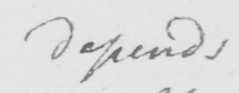Please transcribe the handwritten text in this image. depends 